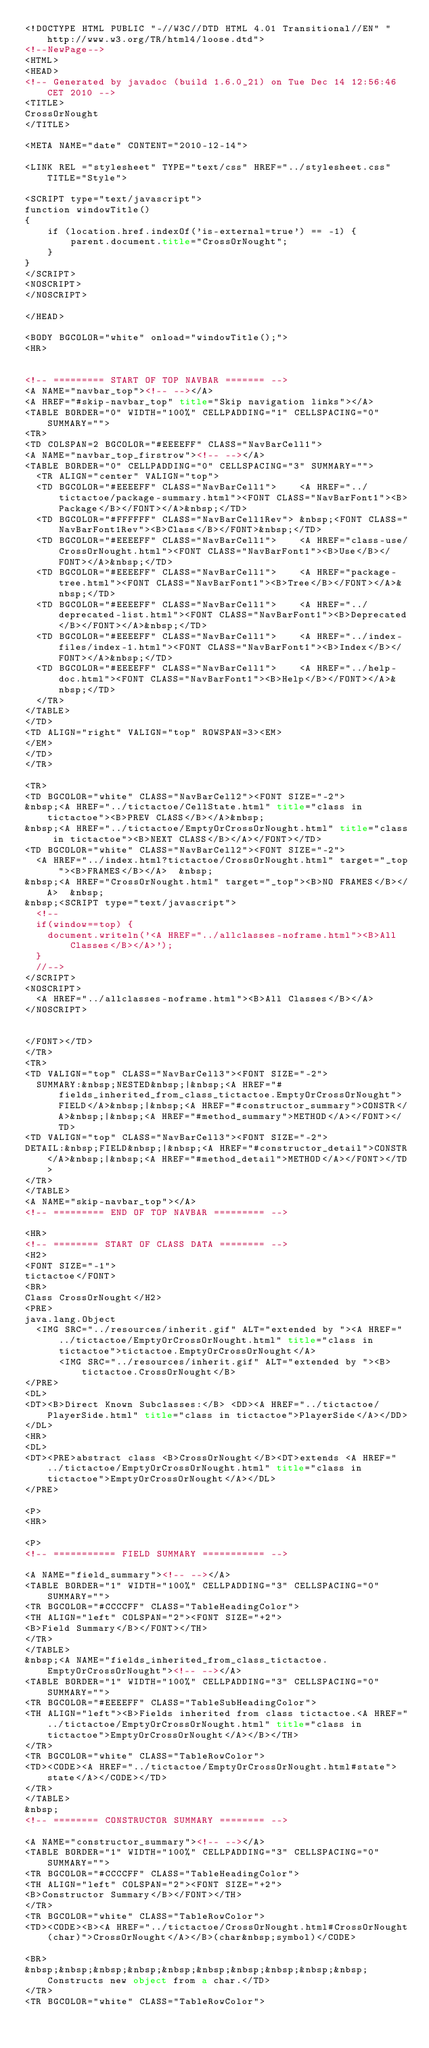Convert code to text. <code><loc_0><loc_0><loc_500><loc_500><_HTML_><!DOCTYPE HTML PUBLIC "-//W3C//DTD HTML 4.01 Transitional//EN" "http://www.w3.org/TR/html4/loose.dtd">
<!--NewPage-->
<HTML>
<HEAD>
<!-- Generated by javadoc (build 1.6.0_21) on Tue Dec 14 12:56:46 CET 2010 -->
<TITLE>
CrossOrNought
</TITLE>

<META NAME="date" CONTENT="2010-12-14">

<LINK REL ="stylesheet" TYPE="text/css" HREF="../stylesheet.css" TITLE="Style">

<SCRIPT type="text/javascript">
function windowTitle()
{
    if (location.href.indexOf('is-external=true') == -1) {
        parent.document.title="CrossOrNought";
    }
}
</SCRIPT>
<NOSCRIPT>
</NOSCRIPT>

</HEAD>

<BODY BGCOLOR="white" onload="windowTitle();">
<HR>


<!-- ========= START OF TOP NAVBAR ======= -->
<A NAME="navbar_top"><!-- --></A>
<A HREF="#skip-navbar_top" title="Skip navigation links"></A>
<TABLE BORDER="0" WIDTH="100%" CELLPADDING="1" CELLSPACING="0" SUMMARY="">
<TR>
<TD COLSPAN=2 BGCOLOR="#EEEEFF" CLASS="NavBarCell1">
<A NAME="navbar_top_firstrow"><!-- --></A>
<TABLE BORDER="0" CELLPADDING="0" CELLSPACING="3" SUMMARY="">
  <TR ALIGN="center" VALIGN="top">
  <TD BGCOLOR="#EEEEFF" CLASS="NavBarCell1">    <A HREF="../tictactoe/package-summary.html"><FONT CLASS="NavBarFont1"><B>Package</B></FONT></A>&nbsp;</TD>
  <TD BGCOLOR="#FFFFFF" CLASS="NavBarCell1Rev"> &nbsp;<FONT CLASS="NavBarFont1Rev"><B>Class</B></FONT>&nbsp;</TD>
  <TD BGCOLOR="#EEEEFF" CLASS="NavBarCell1">    <A HREF="class-use/CrossOrNought.html"><FONT CLASS="NavBarFont1"><B>Use</B></FONT></A>&nbsp;</TD>
  <TD BGCOLOR="#EEEEFF" CLASS="NavBarCell1">    <A HREF="package-tree.html"><FONT CLASS="NavBarFont1"><B>Tree</B></FONT></A>&nbsp;</TD>
  <TD BGCOLOR="#EEEEFF" CLASS="NavBarCell1">    <A HREF="../deprecated-list.html"><FONT CLASS="NavBarFont1"><B>Deprecated</B></FONT></A>&nbsp;</TD>
  <TD BGCOLOR="#EEEEFF" CLASS="NavBarCell1">    <A HREF="../index-files/index-1.html"><FONT CLASS="NavBarFont1"><B>Index</B></FONT></A>&nbsp;</TD>
  <TD BGCOLOR="#EEEEFF" CLASS="NavBarCell1">    <A HREF="../help-doc.html"><FONT CLASS="NavBarFont1"><B>Help</B></FONT></A>&nbsp;</TD>
  </TR>
</TABLE>
</TD>
<TD ALIGN="right" VALIGN="top" ROWSPAN=3><EM>
</EM>
</TD>
</TR>

<TR>
<TD BGCOLOR="white" CLASS="NavBarCell2"><FONT SIZE="-2">
&nbsp;<A HREF="../tictactoe/CellState.html" title="class in tictactoe"><B>PREV CLASS</B></A>&nbsp;
&nbsp;<A HREF="../tictactoe/EmptyOrCrossOrNought.html" title="class in tictactoe"><B>NEXT CLASS</B></A></FONT></TD>
<TD BGCOLOR="white" CLASS="NavBarCell2"><FONT SIZE="-2">
  <A HREF="../index.html?tictactoe/CrossOrNought.html" target="_top"><B>FRAMES</B></A>  &nbsp;
&nbsp;<A HREF="CrossOrNought.html" target="_top"><B>NO FRAMES</B></A>  &nbsp;
&nbsp;<SCRIPT type="text/javascript">
  <!--
  if(window==top) {
    document.writeln('<A HREF="../allclasses-noframe.html"><B>All Classes</B></A>');
  }
  //-->
</SCRIPT>
<NOSCRIPT>
  <A HREF="../allclasses-noframe.html"><B>All Classes</B></A>
</NOSCRIPT>


</FONT></TD>
</TR>
<TR>
<TD VALIGN="top" CLASS="NavBarCell3"><FONT SIZE="-2">
  SUMMARY:&nbsp;NESTED&nbsp;|&nbsp;<A HREF="#fields_inherited_from_class_tictactoe.EmptyOrCrossOrNought">FIELD</A>&nbsp;|&nbsp;<A HREF="#constructor_summary">CONSTR</A>&nbsp;|&nbsp;<A HREF="#method_summary">METHOD</A></FONT></TD>
<TD VALIGN="top" CLASS="NavBarCell3"><FONT SIZE="-2">
DETAIL:&nbsp;FIELD&nbsp;|&nbsp;<A HREF="#constructor_detail">CONSTR</A>&nbsp;|&nbsp;<A HREF="#method_detail">METHOD</A></FONT></TD>
</TR>
</TABLE>
<A NAME="skip-navbar_top"></A>
<!-- ========= END OF TOP NAVBAR ========= -->

<HR>
<!-- ======== START OF CLASS DATA ======== -->
<H2>
<FONT SIZE="-1">
tictactoe</FONT>
<BR>
Class CrossOrNought</H2>
<PRE>
java.lang.Object
  <IMG SRC="../resources/inherit.gif" ALT="extended by "><A HREF="../tictactoe/EmptyOrCrossOrNought.html" title="class in tictactoe">tictactoe.EmptyOrCrossOrNought</A>
      <IMG SRC="../resources/inherit.gif" ALT="extended by "><B>tictactoe.CrossOrNought</B>
</PRE>
<DL>
<DT><B>Direct Known Subclasses:</B> <DD><A HREF="../tictactoe/PlayerSide.html" title="class in tictactoe">PlayerSide</A></DD>
</DL>
<HR>
<DL>
<DT><PRE>abstract class <B>CrossOrNought</B><DT>extends <A HREF="../tictactoe/EmptyOrCrossOrNought.html" title="class in tictactoe">EmptyOrCrossOrNought</A></DL>
</PRE>

<P>
<HR>

<P>
<!-- =========== FIELD SUMMARY =========== -->

<A NAME="field_summary"><!-- --></A>
<TABLE BORDER="1" WIDTH="100%" CELLPADDING="3" CELLSPACING="0" SUMMARY="">
<TR BGCOLOR="#CCCCFF" CLASS="TableHeadingColor">
<TH ALIGN="left" COLSPAN="2"><FONT SIZE="+2">
<B>Field Summary</B></FONT></TH>
</TR>
</TABLE>
&nbsp;<A NAME="fields_inherited_from_class_tictactoe.EmptyOrCrossOrNought"><!-- --></A>
<TABLE BORDER="1" WIDTH="100%" CELLPADDING="3" CELLSPACING="0" SUMMARY="">
<TR BGCOLOR="#EEEEFF" CLASS="TableSubHeadingColor">
<TH ALIGN="left"><B>Fields inherited from class tictactoe.<A HREF="../tictactoe/EmptyOrCrossOrNought.html" title="class in tictactoe">EmptyOrCrossOrNought</A></B></TH>
</TR>
<TR BGCOLOR="white" CLASS="TableRowColor">
<TD><CODE><A HREF="../tictactoe/EmptyOrCrossOrNought.html#state">state</A></CODE></TD>
</TR>
</TABLE>
&nbsp;
<!-- ======== CONSTRUCTOR SUMMARY ======== -->

<A NAME="constructor_summary"><!-- --></A>
<TABLE BORDER="1" WIDTH="100%" CELLPADDING="3" CELLSPACING="0" SUMMARY="">
<TR BGCOLOR="#CCCCFF" CLASS="TableHeadingColor">
<TH ALIGN="left" COLSPAN="2"><FONT SIZE="+2">
<B>Constructor Summary</B></FONT></TH>
</TR>
<TR BGCOLOR="white" CLASS="TableRowColor">
<TD><CODE><B><A HREF="../tictactoe/CrossOrNought.html#CrossOrNought(char)">CrossOrNought</A></B>(char&nbsp;symbol)</CODE>

<BR>
&nbsp;&nbsp;&nbsp;&nbsp;&nbsp;&nbsp;&nbsp;&nbsp;&nbsp;&nbsp;Constructs new object from a char.</TD>
</TR>
<TR BGCOLOR="white" CLASS="TableRowColor"></code> 